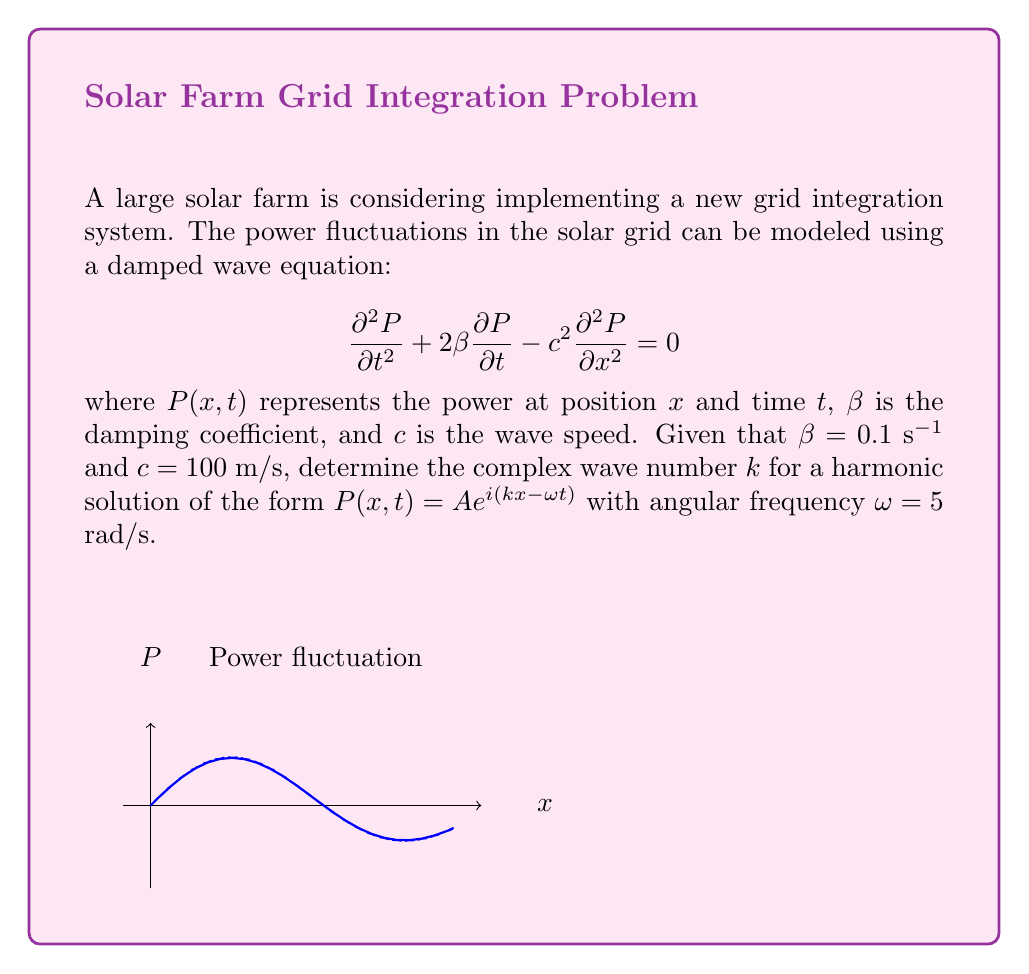Can you solve this math problem? Let's approach this step-by-step:

1) We start with the damped wave equation:
   $$\frac{\partial^2 P}{\partial t^2} + 2\beta \frac{\partial P}{\partial t} - c^2 \frac{\partial^2 P}{\partial x^2} = 0$$

2) We assume a harmonic solution of the form:
   $$P(x,t) = Ae^{i(kx-\omega t)}$$

3) We need to substitute this solution into the wave equation. Let's calculate the derivatives:
   $$\frac{\partial P}{\partial t} = -i\omega Ae^{i(kx-\omega t)}$$
   $$\frac{\partial^2 P}{\partial t^2} = -\omega^2 Ae^{i(kx-\omega t)}$$
   $$\frac{\partial^2 P}{\partial x^2} = -k^2 Ae^{i(kx-\omega t)}$$

4) Substituting these into the wave equation:
   $$(-\omega^2 Ae^{i(kx-\omega t)}) + 2\beta(-i\omega Ae^{i(kx-\omega t)}) - c^2(-k^2 Ae^{i(kx-\omega t)}) = 0$$

5) The $Ae^{i(kx-\omega t)}$ term appears in all parts, so we can divide it out:
   $$-\omega^2 - 2\beta i\omega + c^2k^2 = 0$$

6) Rearranging to solve for $k^2$:
   $$c^2k^2 = \omega^2 + 2\beta i\omega$$
   $$k^2 = \frac{\omega^2 + 2\beta i\omega}{c^2}$$

7) Substituting the given values $\beta = 0.1$ s^(-1), $c = 100$ m/s, and $\omega = 5$ rad/s:
   $$k^2 = \frac{5^2 + 2(0.1)i(5)}{100^2} = \frac{25 + i}{10000}$$

8) To find $k$, we need to take the square root of this complex number:
   $$k = \pm \sqrt{\frac{25 + i}{10000}}$$

9) Using the complex square root formula:
   $$k = \pm \left(\sqrt{\frac{\sqrt{25^2 + 1^2} + 25}{20000}} + i \text{sign}(1) \sqrt{\frac{\sqrt{25^2 + 1^2} - 25}{20000}}\right)$$

10) Simplifying:
    $$k \approx \pm (0.05 + 0.0001i) \text{ m}^{-1}$$
Answer: $k \approx \pm (0.05 + 0.0001i) \text{ m}^{-1}$ 